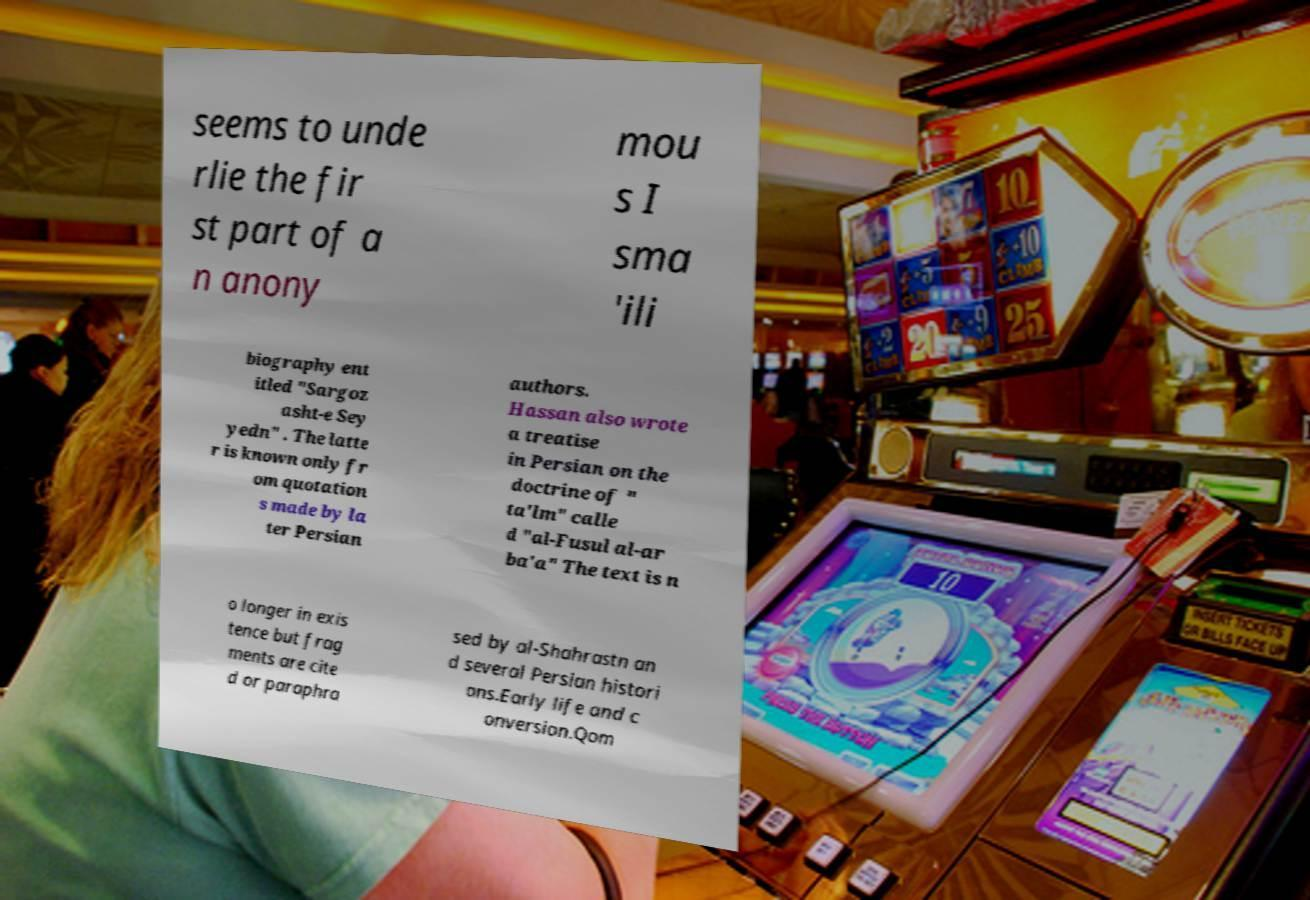Could you assist in decoding the text presented in this image and type it out clearly? seems to unde rlie the fir st part of a n anony mou s I sma 'ili biography ent itled "Sargoz asht-e Sey yedn" . The latte r is known only fr om quotation s made by la ter Persian authors. Hassan also wrote a treatise in Persian on the doctrine of " ta'lm" calle d "al-Fusul al-ar ba'a" The text is n o longer in exis tence but frag ments are cite d or paraphra sed by al-Shahrastn an d several Persian histori ans.Early life and c onversion.Qom 